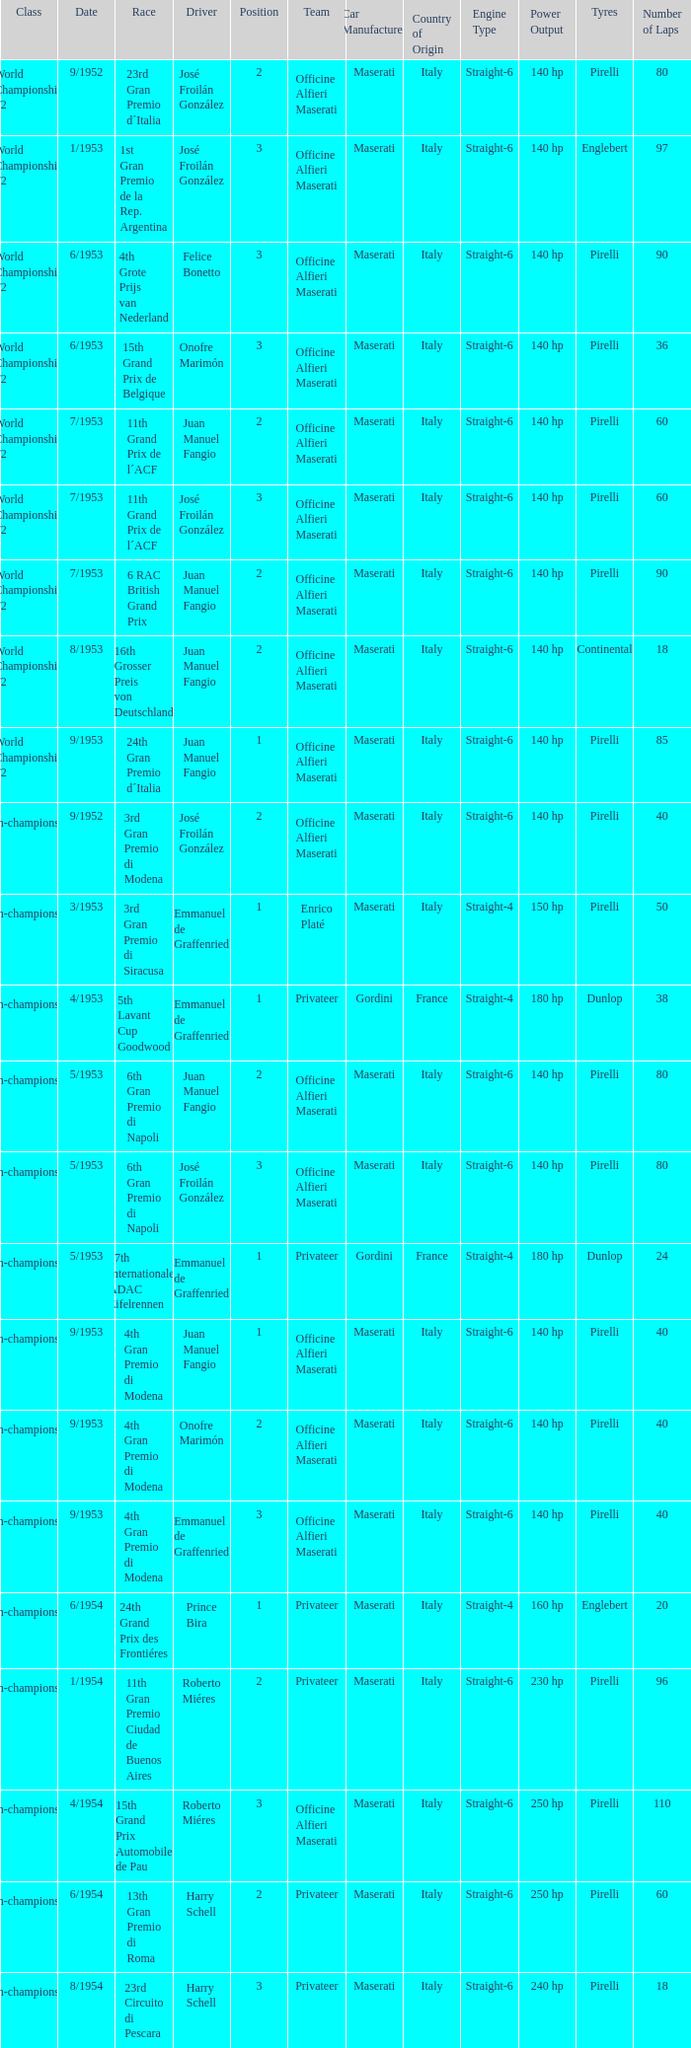What team has a drive name emmanuel de graffenried and a position larger than 1 as well as the date of 9/1953? Officine Alfieri Maserati. 